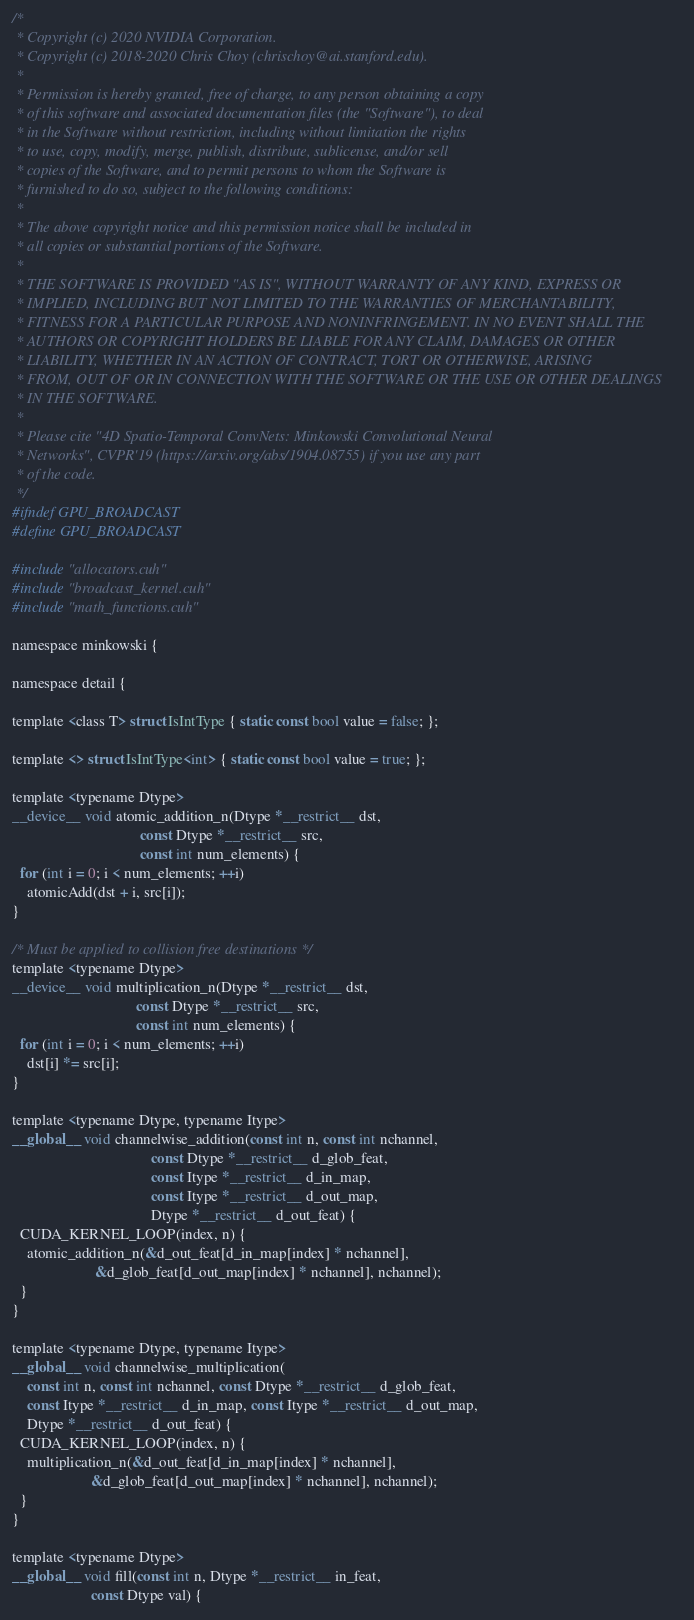Convert code to text. <code><loc_0><loc_0><loc_500><loc_500><_Cuda_>/*
 * Copyright (c) 2020 NVIDIA Corporation.
 * Copyright (c) 2018-2020 Chris Choy (chrischoy@ai.stanford.edu).
 *
 * Permission is hereby granted, free of charge, to any person obtaining a copy
 * of this software and associated documentation files (the "Software"), to deal
 * in the Software without restriction, including without limitation the rights
 * to use, copy, modify, merge, publish, distribute, sublicense, and/or sell
 * copies of the Software, and to permit persons to whom the Software is
 * furnished to do so, subject to the following conditions:
 *
 * The above copyright notice and this permission notice shall be included in
 * all copies or substantial portions of the Software.
 *
 * THE SOFTWARE IS PROVIDED "AS IS", WITHOUT WARRANTY OF ANY KIND, EXPRESS OR
 * IMPLIED, INCLUDING BUT NOT LIMITED TO THE WARRANTIES OF MERCHANTABILITY,
 * FITNESS FOR A PARTICULAR PURPOSE AND NONINFRINGEMENT. IN NO EVENT SHALL THE
 * AUTHORS OR COPYRIGHT HOLDERS BE LIABLE FOR ANY CLAIM, DAMAGES OR OTHER
 * LIABILITY, WHETHER IN AN ACTION OF CONTRACT, TORT OR OTHERWISE, ARISING
 * FROM, OUT OF OR IN CONNECTION WITH THE SOFTWARE OR THE USE OR OTHER DEALINGS
 * IN THE SOFTWARE.
 *
 * Please cite "4D Spatio-Temporal ConvNets: Minkowski Convolutional Neural
 * Networks", CVPR'19 (https://arxiv.org/abs/1904.08755) if you use any part
 * of the code.
 */
#ifndef GPU_BROADCAST
#define GPU_BROADCAST

#include "allocators.cuh"
#include "broadcast_kernel.cuh"
#include "math_functions.cuh"

namespace minkowski {

namespace detail {

template <class T> struct IsIntType { static const bool value = false; };

template <> struct IsIntType<int> { static const bool value = true; };

template <typename Dtype>
__device__ void atomic_addition_n(Dtype *__restrict__ dst,
                                  const Dtype *__restrict__ src,
                                  const int num_elements) {
  for (int i = 0; i < num_elements; ++i)
    atomicAdd(dst + i, src[i]);
}

/* Must be applied to collision free destinations */
template <typename Dtype>
__device__ void multiplication_n(Dtype *__restrict__ dst,
                                 const Dtype *__restrict__ src,
                                 const int num_elements) {
  for (int i = 0; i < num_elements; ++i)
    dst[i] *= src[i];
}

template <typename Dtype, typename Itype>
__global__ void channelwise_addition(const int n, const int nchannel,
                                     const Dtype *__restrict__ d_glob_feat,
                                     const Itype *__restrict__ d_in_map,
                                     const Itype *__restrict__ d_out_map,
                                     Dtype *__restrict__ d_out_feat) {
  CUDA_KERNEL_LOOP(index, n) {
    atomic_addition_n(&d_out_feat[d_in_map[index] * nchannel],
                      &d_glob_feat[d_out_map[index] * nchannel], nchannel);
  }
}

template <typename Dtype, typename Itype>
__global__ void channelwise_multiplication(
    const int n, const int nchannel, const Dtype *__restrict__ d_glob_feat,
    const Itype *__restrict__ d_in_map, const Itype *__restrict__ d_out_map,
    Dtype *__restrict__ d_out_feat) {
  CUDA_KERNEL_LOOP(index, n) {
    multiplication_n(&d_out_feat[d_in_map[index] * nchannel],
                     &d_glob_feat[d_out_map[index] * nchannel], nchannel);
  }
}

template <typename Dtype>
__global__ void fill(const int n, Dtype *__restrict__ in_feat,
                     const Dtype val) {</code> 